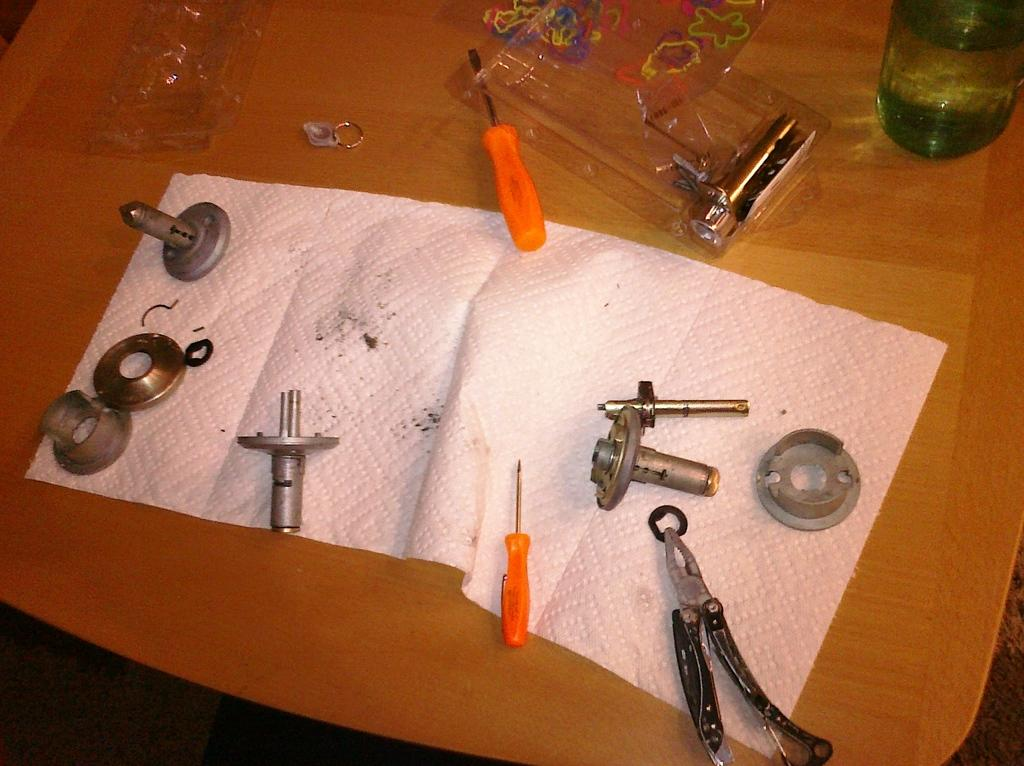What type of tools can be seen in the image? There are screwdrivers in the image. What else is present on the table in the image? There is a paper, a bottle, and other tools and objects on the table in the image. How many ducks are visible in the image? There are no ducks present in the image. Can you tell me how much money is in the account shown in the image? There is no account or financial information present in the image. 